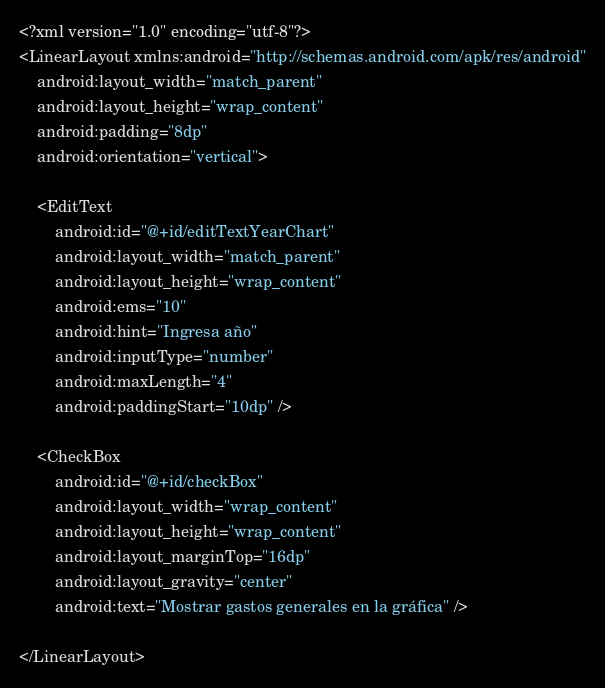<code> <loc_0><loc_0><loc_500><loc_500><_XML_><?xml version="1.0" encoding="utf-8"?>
<LinearLayout xmlns:android="http://schemas.android.com/apk/res/android"
    android:layout_width="match_parent"
    android:layout_height="wrap_content"
    android:padding="8dp"
    android:orientation="vertical">

    <EditText
        android:id="@+id/editTextYearChart"
        android:layout_width="match_parent"
        android:layout_height="wrap_content"
        android:ems="10"
        android:hint="Ingresa año"
        android:inputType="number"
        android:maxLength="4"
        android:paddingStart="10dp" />

    <CheckBox
        android:id="@+id/checkBox"
        android:layout_width="wrap_content"
        android:layout_height="wrap_content"
        android:layout_marginTop="16dp"
        android:layout_gravity="center"
        android:text="Mostrar gastos generales en la gráfica" />

</LinearLayout></code> 